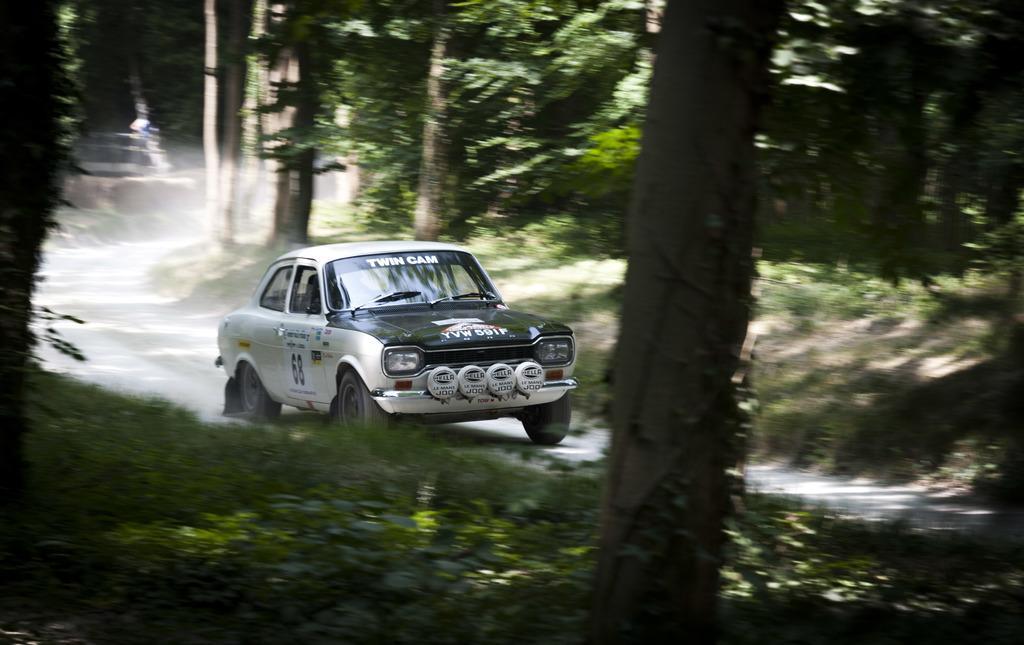Can you describe this image briefly? In this image we can see a car on the road. We can also see a bark of a tree, plants and some trees. 